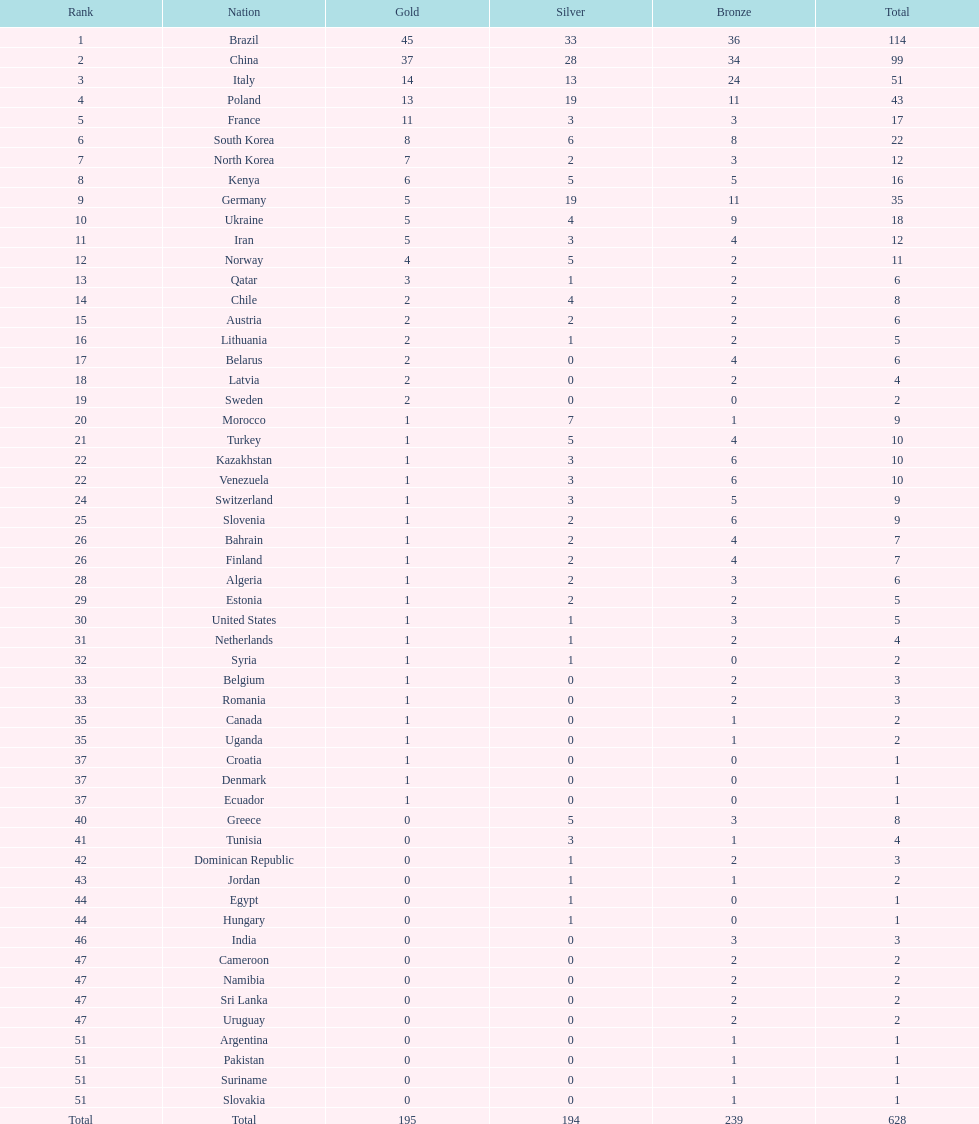Give me the full table as a dictionary. {'header': ['Rank', 'Nation', 'Gold', 'Silver', 'Bronze', 'Total'], 'rows': [['1', 'Brazil', '45', '33', '36', '114'], ['2', 'China', '37', '28', '34', '99'], ['3', 'Italy', '14', '13', '24', '51'], ['4', 'Poland', '13', '19', '11', '43'], ['5', 'France', '11', '3', '3', '17'], ['6', 'South Korea', '8', '6', '8', '22'], ['7', 'North Korea', '7', '2', '3', '12'], ['8', 'Kenya', '6', '5', '5', '16'], ['9', 'Germany', '5', '19', '11', '35'], ['10', 'Ukraine', '5', '4', '9', '18'], ['11', 'Iran', '5', '3', '4', '12'], ['12', 'Norway', '4', '5', '2', '11'], ['13', 'Qatar', '3', '1', '2', '6'], ['14', 'Chile', '2', '4', '2', '8'], ['15', 'Austria', '2', '2', '2', '6'], ['16', 'Lithuania', '2', '1', '2', '5'], ['17', 'Belarus', '2', '0', '4', '6'], ['18', 'Latvia', '2', '0', '2', '4'], ['19', 'Sweden', '2', '0', '0', '2'], ['20', 'Morocco', '1', '7', '1', '9'], ['21', 'Turkey', '1', '5', '4', '10'], ['22', 'Kazakhstan', '1', '3', '6', '10'], ['22', 'Venezuela', '1', '3', '6', '10'], ['24', 'Switzerland', '1', '3', '5', '9'], ['25', 'Slovenia', '1', '2', '6', '9'], ['26', 'Bahrain', '1', '2', '4', '7'], ['26', 'Finland', '1', '2', '4', '7'], ['28', 'Algeria', '1', '2', '3', '6'], ['29', 'Estonia', '1', '2', '2', '5'], ['30', 'United States', '1', '1', '3', '5'], ['31', 'Netherlands', '1', '1', '2', '4'], ['32', 'Syria', '1', '1', '0', '2'], ['33', 'Belgium', '1', '0', '2', '3'], ['33', 'Romania', '1', '0', '2', '3'], ['35', 'Canada', '1', '0', '1', '2'], ['35', 'Uganda', '1', '0', '1', '2'], ['37', 'Croatia', '1', '0', '0', '1'], ['37', 'Denmark', '1', '0', '0', '1'], ['37', 'Ecuador', '1', '0', '0', '1'], ['40', 'Greece', '0', '5', '3', '8'], ['41', 'Tunisia', '0', '3', '1', '4'], ['42', 'Dominican Republic', '0', '1', '2', '3'], ['43', 'Jordan', '0', '1', '1', '2'], ['44', 'Egypt', '0', '1', '0', '1'], ['44', 'Hungary', '0', '1', '0', '1'], ['46', 'India', '0', '0', '3', '3'], ['47', 'Cameroon', '0', '0', '2', '2'], ['47', 'Namibia', '0', '0', '2', '2'], ['47', 'Sri Lanka', '0', '0', '2', '2'], ['47', 'Uruguay', '0', '0', '2', '2'], ['51', 'Argentina', '0', '0', '1', '1'], ['51', 'Pakistan', '0', '0', '1', '1'], ['51', 'Suriname', '0', '0', '1', '1'], ['51', 'Slovakia', '0', '0', '1', '1'], ['Total', 'Total', '195', '194', '239', '628']]} Which nation earned the most gold medals? Brazil. 